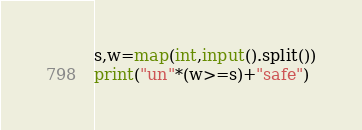<code> <loc_0><loc_0><loc_500><loc_500><_Python_>s,w=map(int,input().split())
print("un"*(w>=s)+"safe")</code> 